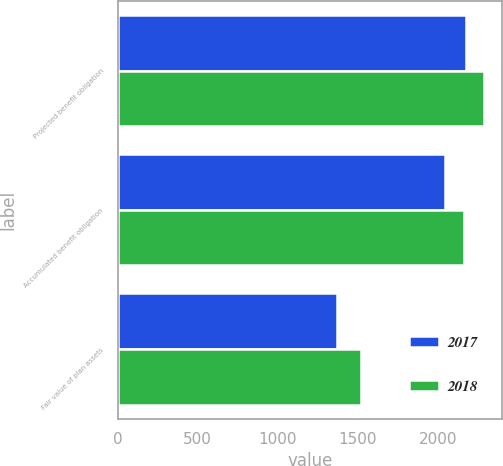<chart> <loc_0><loc_0><loc_500><loc_500><stacked_bar_chart><ecel><fcel>Projected benefit obligation<fcel>Accumulated benefit obligation<fcel>Fair value of plan assets<nl><fcel>2017<fcel>2177<fcel>2048<fcel>1373<nl><fcel>2018<fcel>2287<fcel>2163<fcel>1521<nl></chart> 